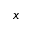Convert formula to latex. <formula><loc_0><loc_0><loc_500><loc_500>x</formula> 